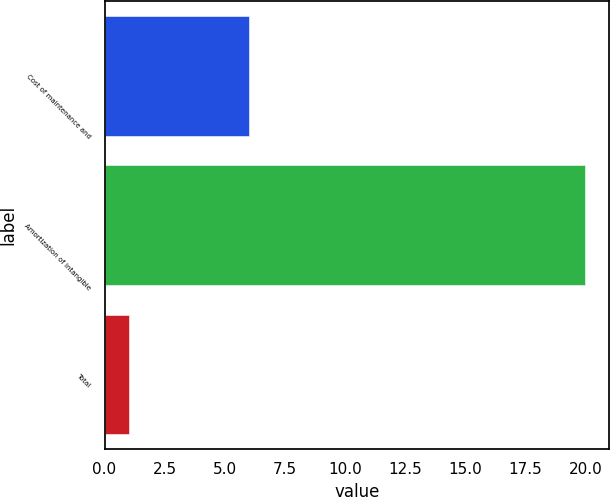Convert chart. <chart><loc_0><loc_0><loc_500><loc_500><bar_chart><fcel>Cost of maintenance and<fcel>Amortization of intangible<fcel>Total<nl><fcel>6<fcel>20<fcel>1<nl></chart> 